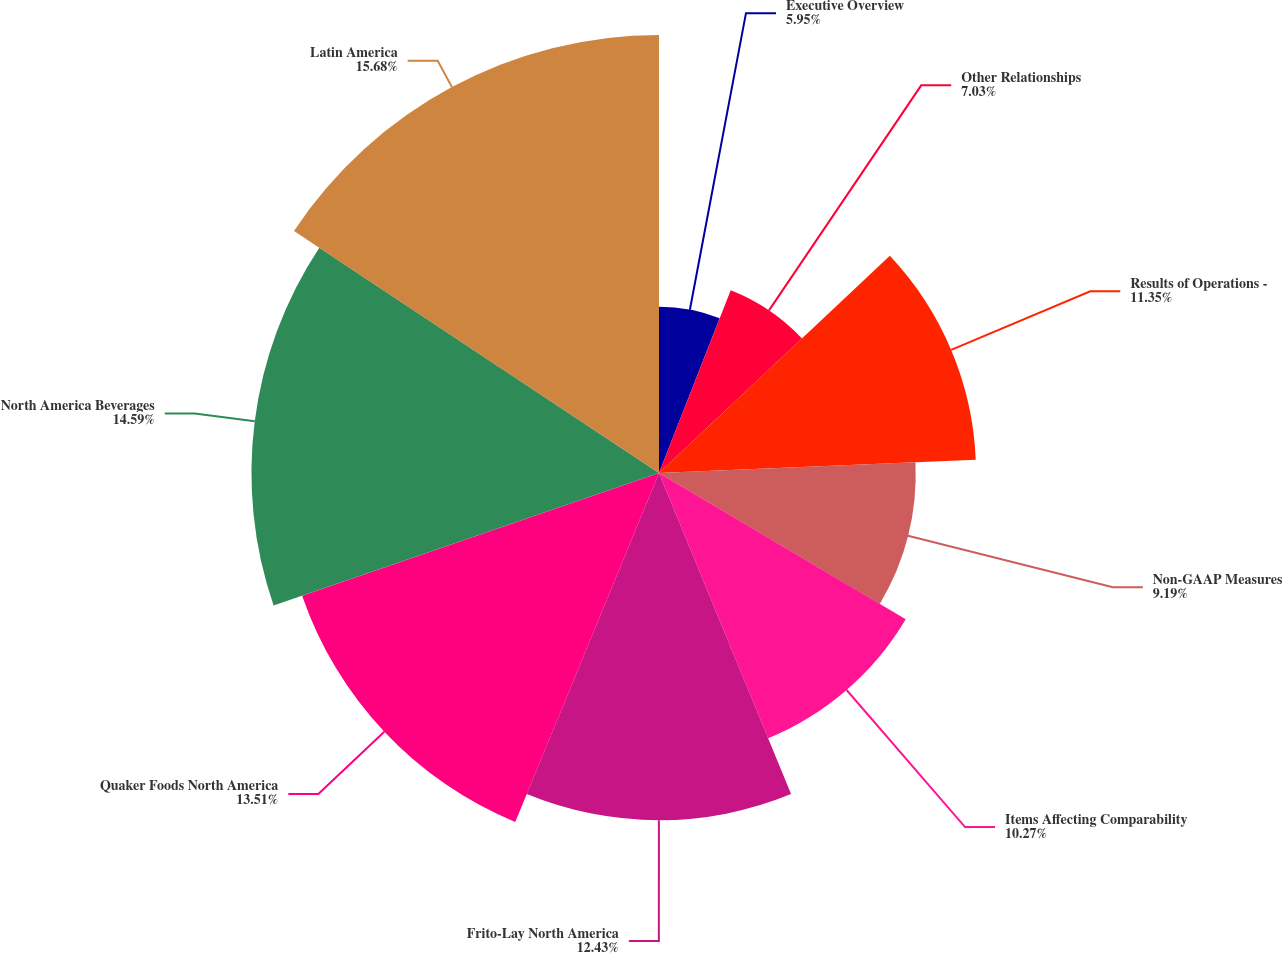Convert chart. <chart><loc_0><loc_0><loc_500><loc_500><pie_chart><fcel>Executive Overview<fcel>Other Relationships<fcel>Results of Operations -<fcel>Non-GAAP Measures<fcel>Items Affecting Comparability<fcel>Frito-Lay North America<fcel>Quaker Foods North America<fcel>North America Beverages<fcel>Latin America<nl><fcel>5.95%<fcel>7.03%<fcel>11.35%<fcel>9.19%<fcel>10.27%<fcel>12.43%<fcel>13.51%<fcel>14.59%<fcel>15.68%<nl></chart> 